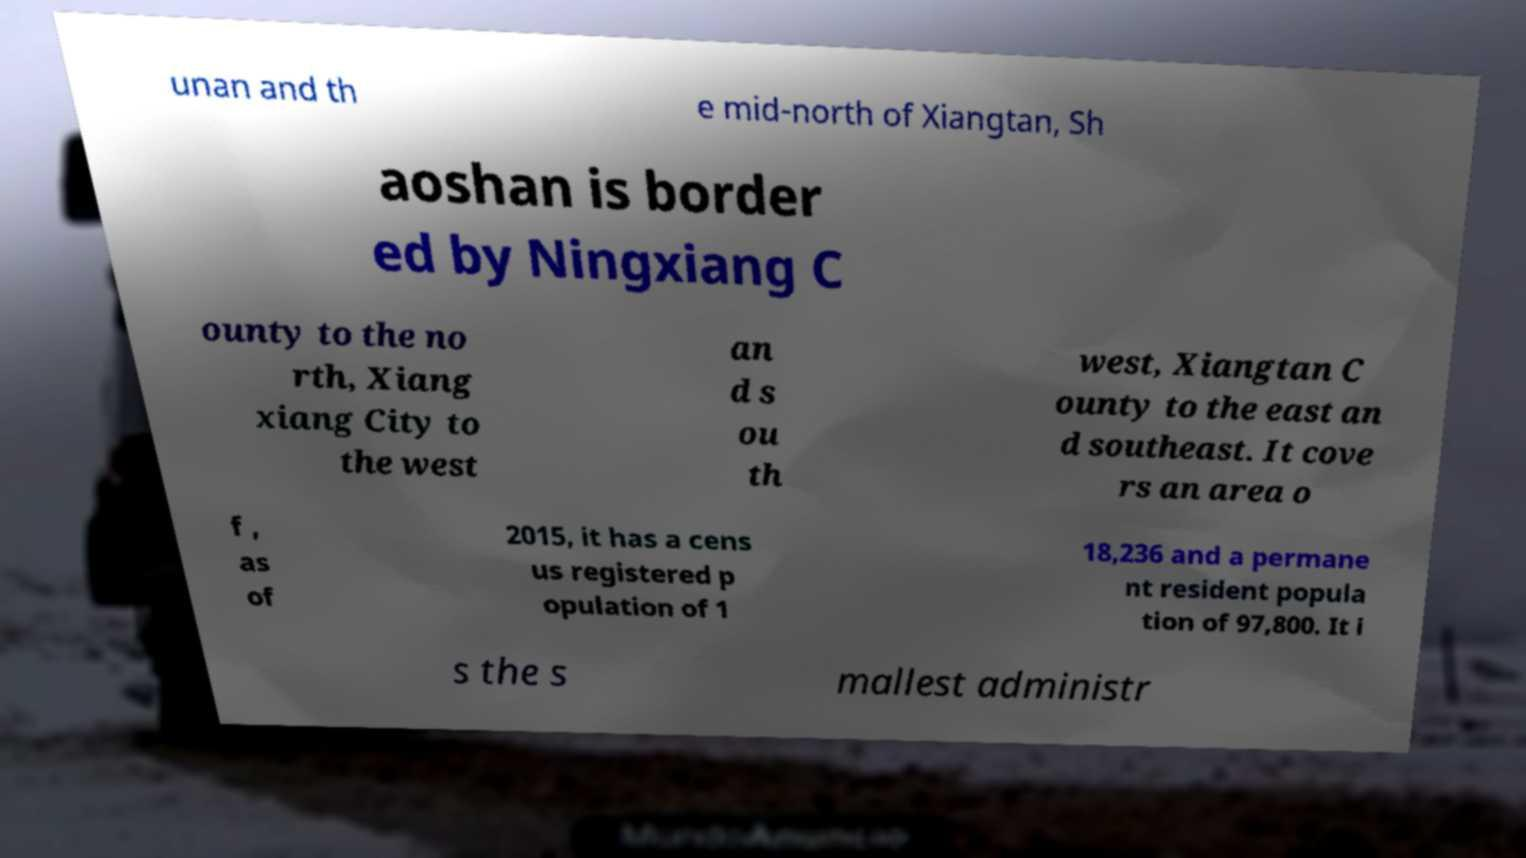Please read and relay the text visible in this image. What does it say? unan and th e mid-north of Xiangtan, Sh aoshan is border ed by Ningxiang C ounty to the no rth, Xiang xiang City to the west an d s ou th west, Xiangtan C ounty to the east an d southeast. It cove rs an area o f , as of 2015, it has a cens us registered p opulation of 1 18,236 and a permane nt resident popula tion of 97,800. It i s the s mallest administr 